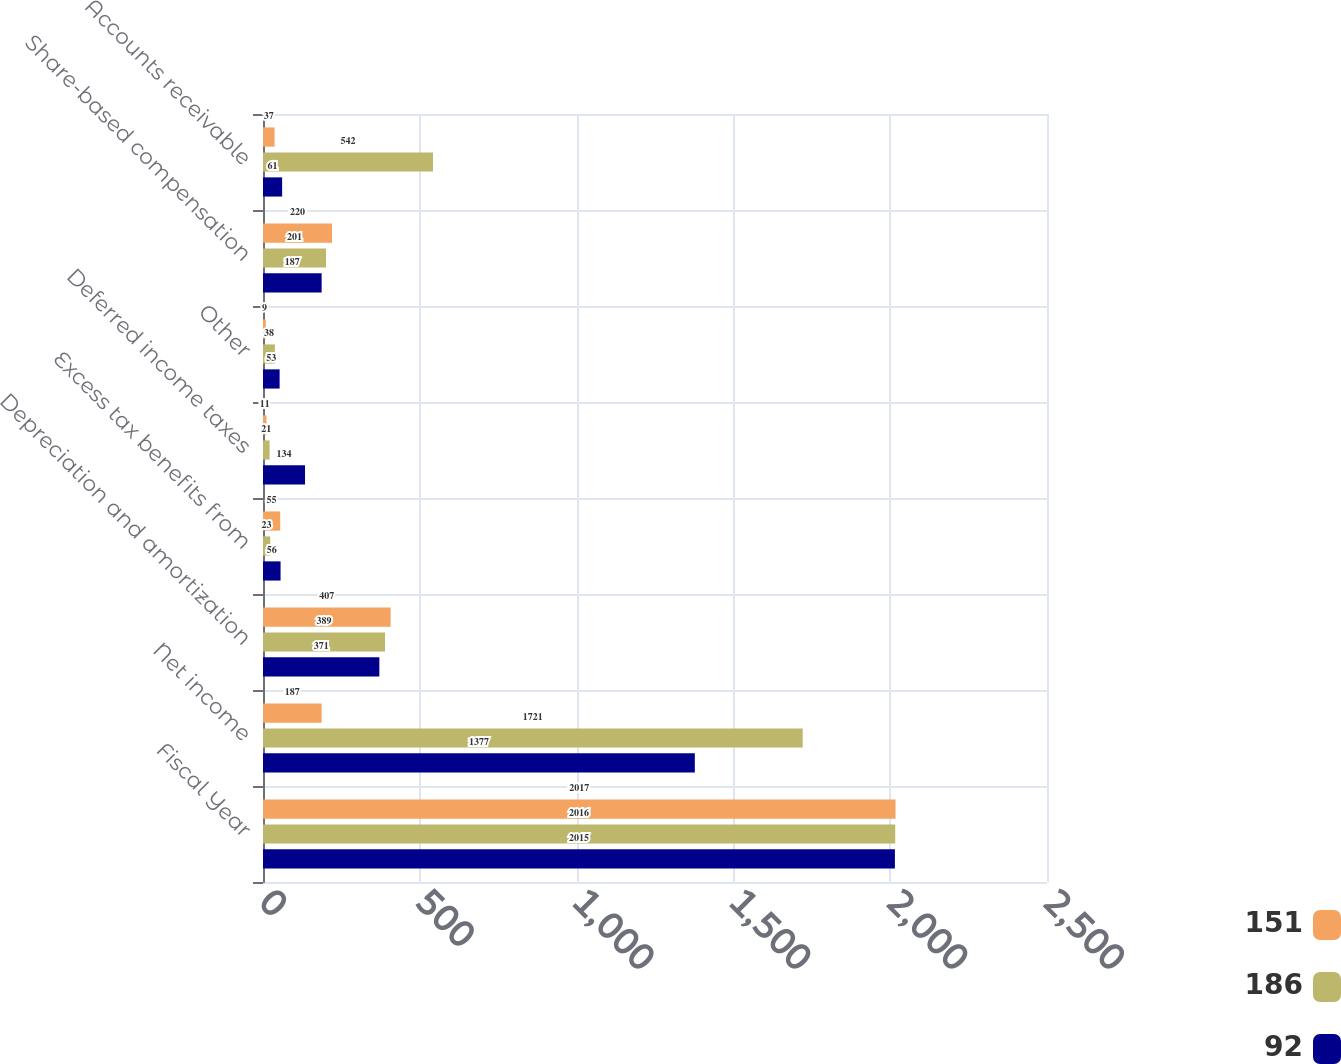Convert chart. <chart><loc_0><loc_0><loc_500><loc_500><stacked_bar_chart><ecel><fcel>Fiscal Year<fcel>Net income<fcel>Depreciation and amortization<fcel>Excess tax benefits from<fcel>Deferred income taxes<fcel>Other<fcel>Share-based compensation<fcel>Accounts receivable<nl><fcel>151<fcel>2017<fcel>187<fcel>407<fcel>55<fcel>11<fcel>9<fcel>220<fcel>37<nl><fcel>186<fcel>2016<fcel>1721<fcel>389<fcel>23<fcel>21<fcel>38<fcel>201<fcel>542<nl><fcel>92<fcel>2015<fcel>1377<fcel>371<fcel>56<fcel>134<fcel>53<fcel>187<fcel>61<nl></chart> 